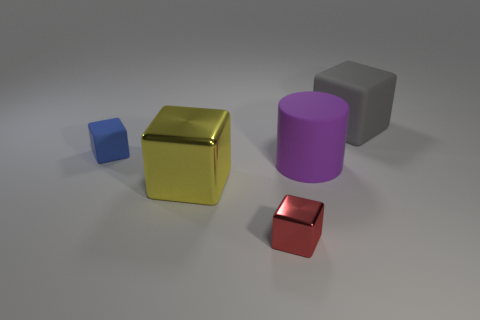How many small red shiny objects are on the right side of the big block in front of the tiny cube that is to the left of the red metallic cube?
Your answer should be very brief. 1. Is the color of the cube on the right side of the big purple rubber object the same as the large thing that is on the left side of the big purple matte object?
Give a very brief answer. No. There is a cube that is both behind the large purple rubber cylinder and to the left of the large matte cylinder; what color is it?
Your answer should be very brief. Blue. What number of other things are the same size as the blue matte thing?
Provide a short and direct response. 1. The big matte object in front of the tiny object to the left of the big metallic thing is what shape?
Your answer should be compact. Cylinder. The matte object in front of the rubber cube on the left side of the cube right of the cylinder is what shape?
Your answer should be compact. Cylinder. What number of other blue things are the same shape as the tiny metal thing?
Make the answer very short. 1. What number of purple rubber objects are on the right side of the cube that is right of the purple matte object?
Your answer should be very brief. 0. What number of shiny objects are either tiny blue blocks or large purple cylinders?
Keep it short and to the point. 0. Is there another object that has the same material as the large gray object?
Ensure brevity in your answer.  Yes. 